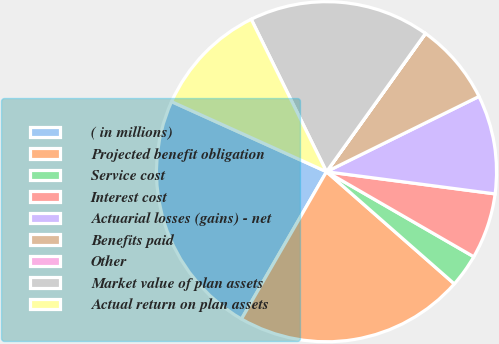Convert chart to OTSL. <chart><loc_0><loc_0><loc_500><loc_500><pie_chart><fcel>( in millions)<fcel>Projected benefit obligation<fcel>Service cost<fcel>Interest cost<fcel>Actuarial losses (gains) - net<fcel>Benefits paid<fcel>Other<fcel>Market value of plan assets<fcel>Actual return on plan assets<nl><fcel>23.43%<fcel>21.87%<fcel>3.13%<fcel>6.25%<fcel>9.38%<fcel>7.81%<fcel>0.01%<fcel>17.18%<fcel>10.94%<nl></chart> 